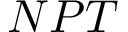Convert formula to latex. <formula><loc_0><loc_0><loc_500><loc_500>N P T</formula> 